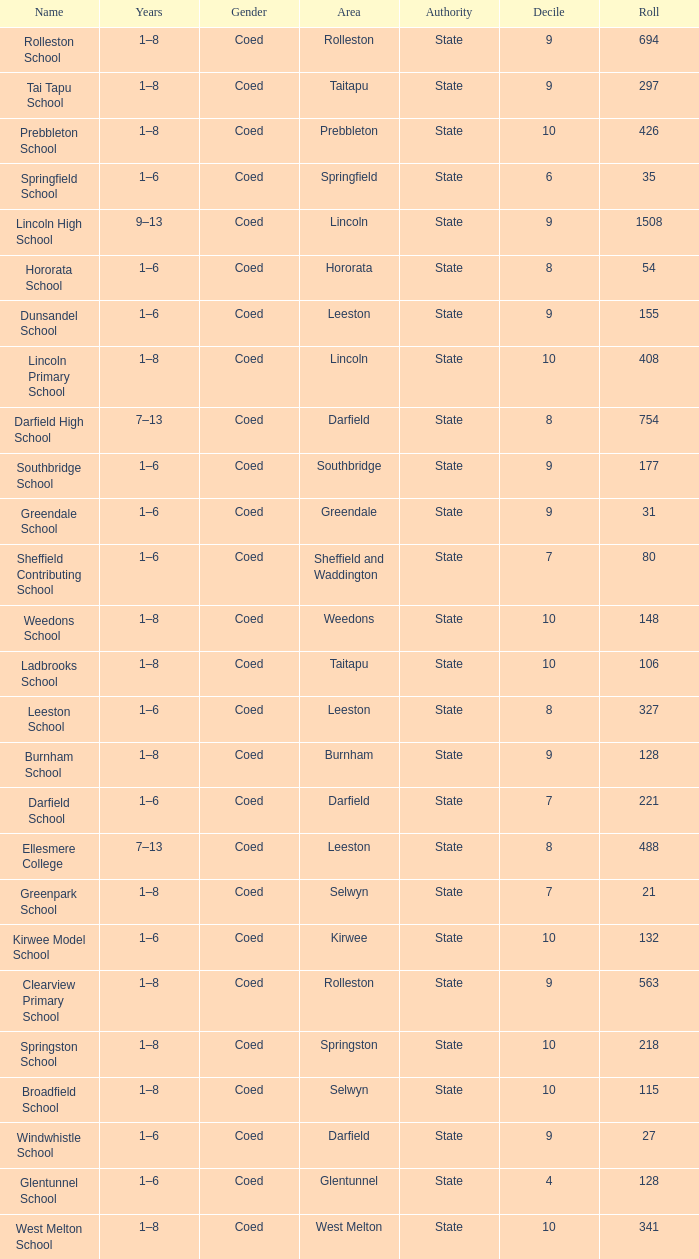How many deciles have Years of 9–13? 1.0. 